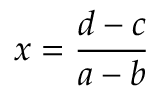Convert formula to latex. <formula><loc_0><loc_0><loc_500><loc_500>x = { \frac { d - c } { a - b } }</formula> 